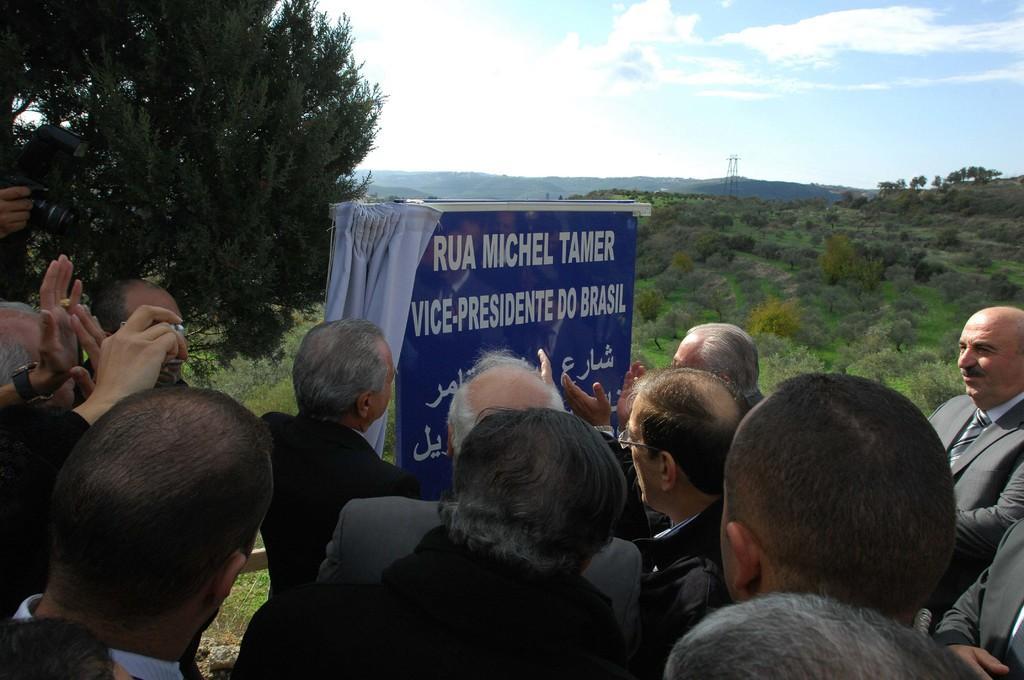Could you give a brief overview of what you see in this image? There are persons in different color dresses standing in front of a name board which is having a curtain. In the background, there are trees and plants on the ground, mountains and there are clouds in the sky. 